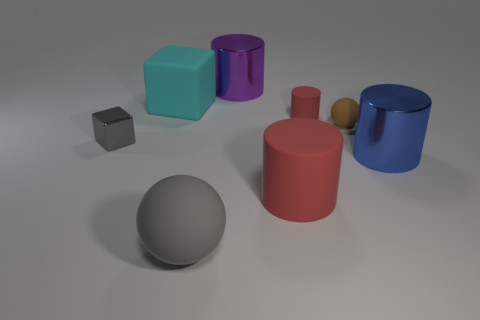What number of rubber objects are either green things or tiny things?
Offer a very short reply. 2. There is a large rubber thing behind the red thing that is behind the small brown thing; is there a tiny brown matte sphere to the left of it?
Your response must be concise. No. What is the size of the gray ball that is made of the same material as the cyan cube?
Offer a very short reply. Large. There is a purple cylinder; are there any blue objects to the right of it?
Your answer should be very brief. Yes. Are there any big gray rubber things that are behind the gray object behind the big matte ball?
Your response must be concise. No. There is a matte sphere in front of the small brown ball; is it the same size as the shiny cylinder that is left of the large red cylinder?
Your response must be concise. Yes. How many large things are either red rubber cylinders or balls?
Your answer should be compact. 2. What is the material of the big cylinder that is behind the small object in front of the brown matte thing?
Keep it short and to the point. Metal. The rubber object that is the same color as the big matte cylinder is what shape?
Your answer should be very brief. Cylinder. Is there a large object made of the same material as the gray sphere?
Give a very brief answer. Yes. 